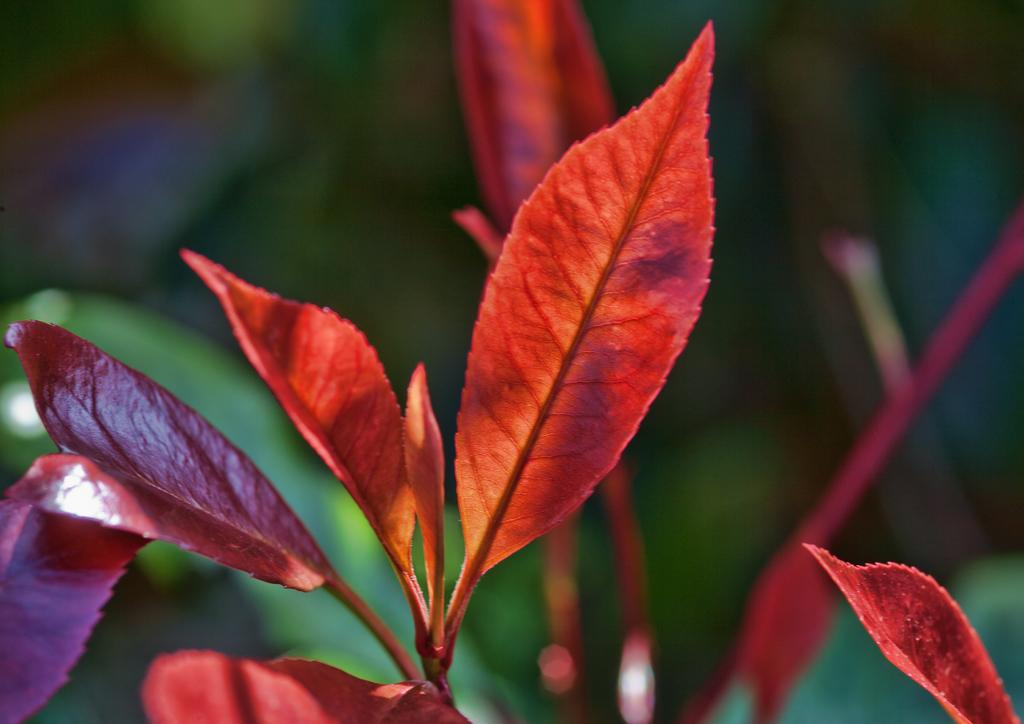What type of leaves can be seen in the image? There are colored leaves in the image. Can you describe the background of the image? The background behind the leaves is blurred. How many pies are present in the image? There are no pies present in the image; it features colored leaves with a blurred background. 